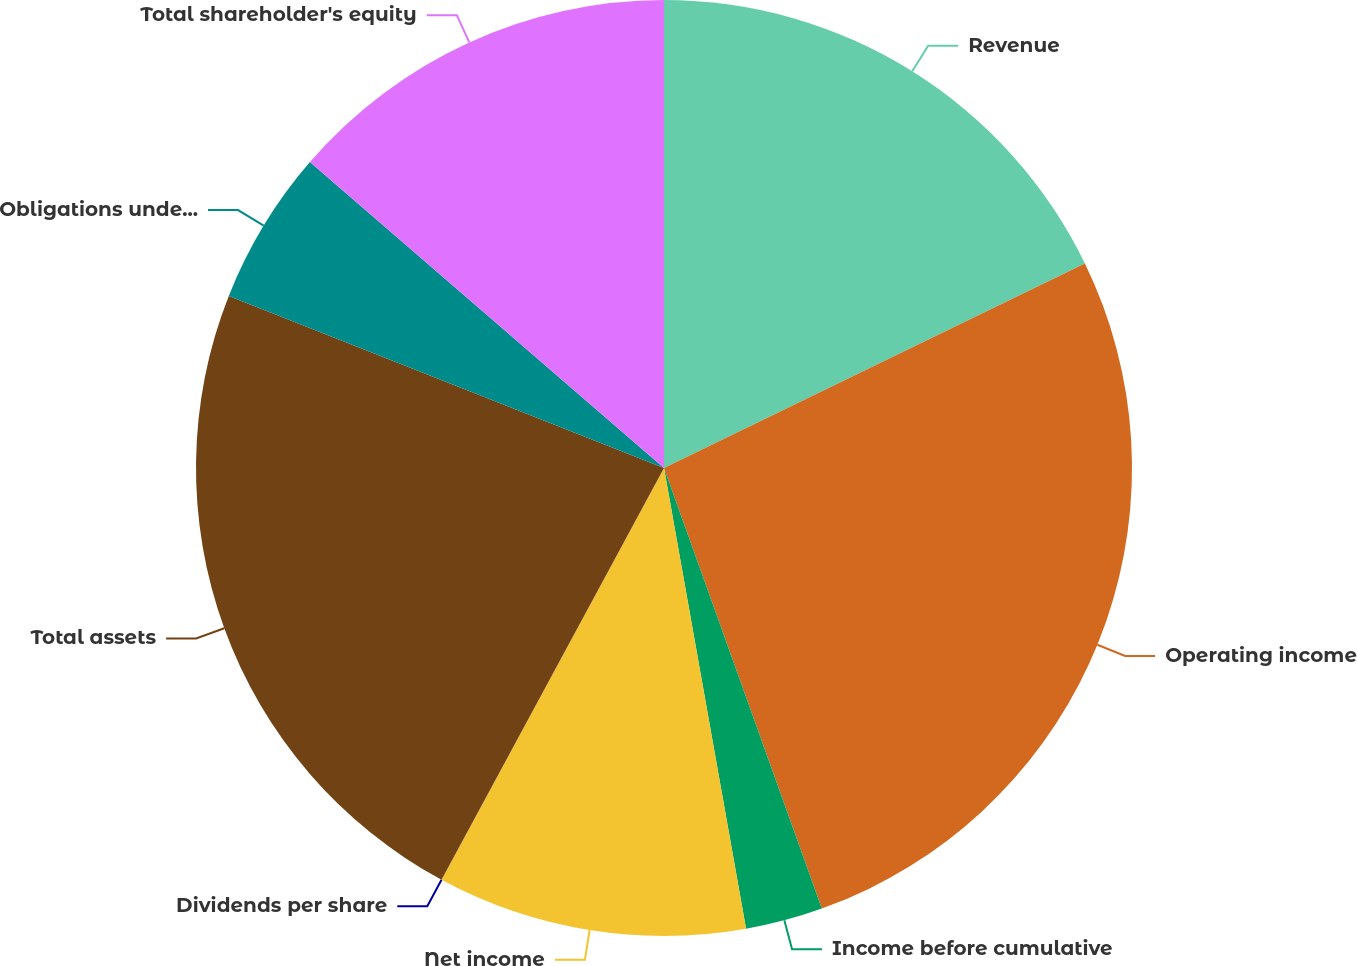Convert chart to OTSL. <chart><loc_0><loc_0><loc_500><loc_500><pie_chart><fcel>Revenue<fcel>Operating income<fcel>Income before cumulative<fcel>Net income<fcel>Dividends per share<fcel>Total assets<fcel>Obligations under capital<fcel>Total shareholder's equity<nl><fcel>17.8%<fcel>26.73%<fcel>2.67%<fcel>10.69%<fcel>0.0%<fcel>23.11%<fcel>5.35%<fcel>13.66%<nl></chart> 